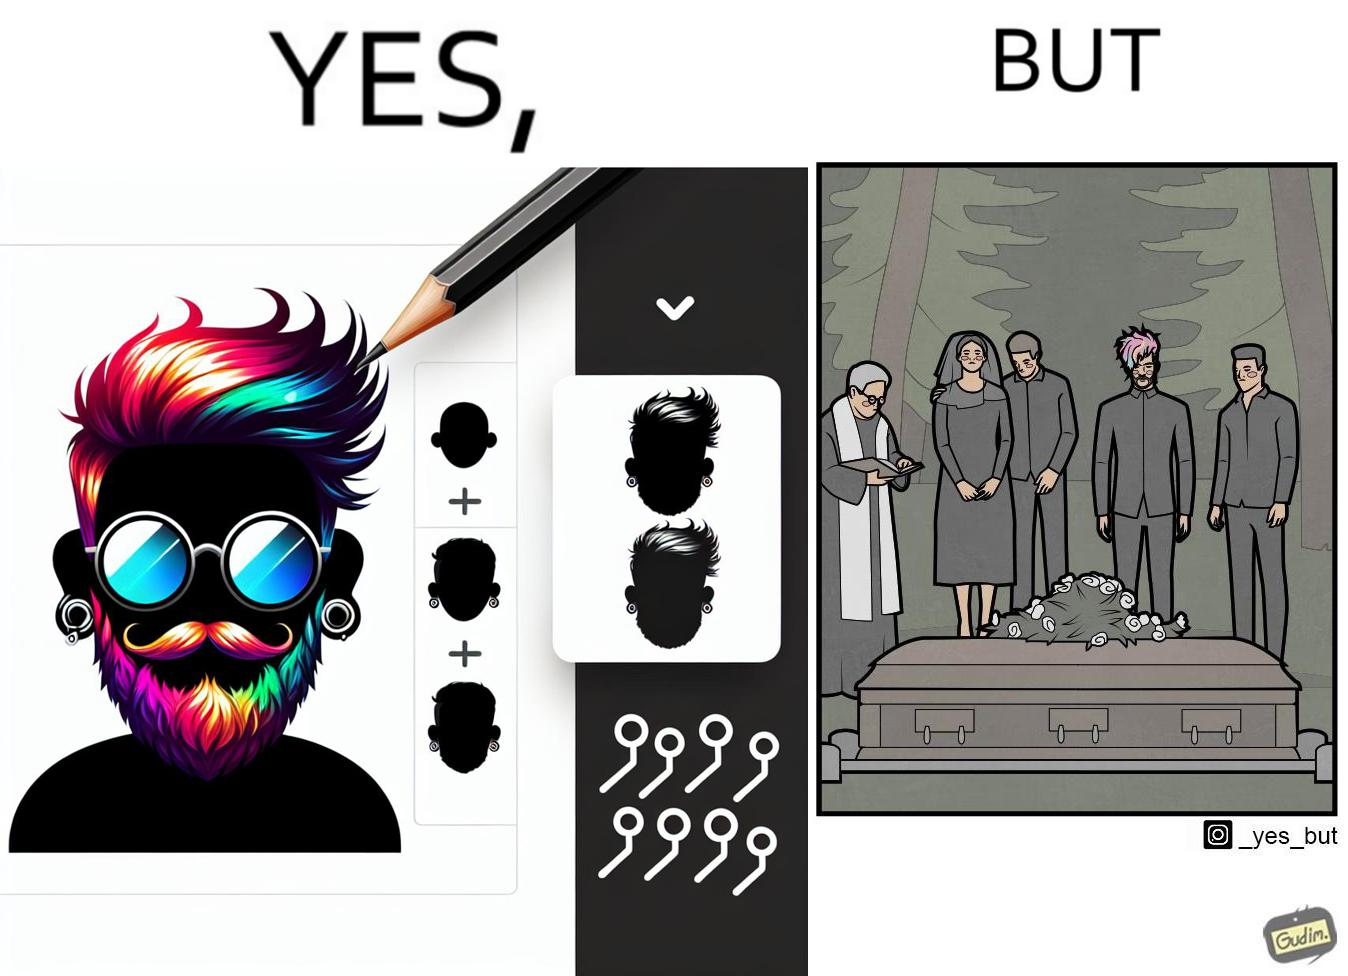Does this image contain satire or humor? Yes, this image is satirical. 